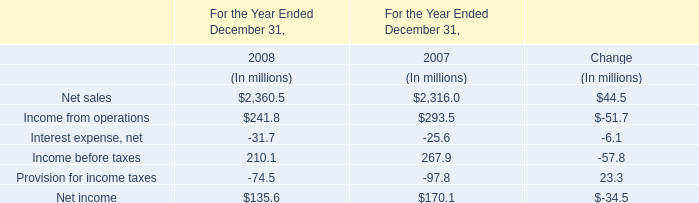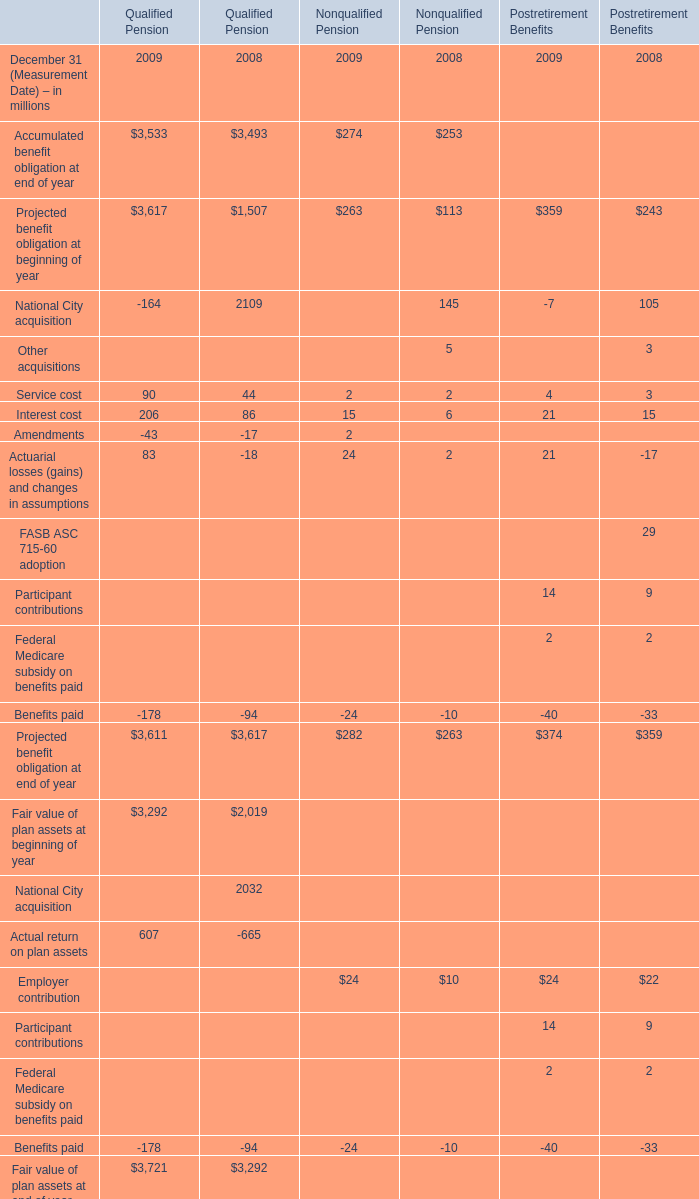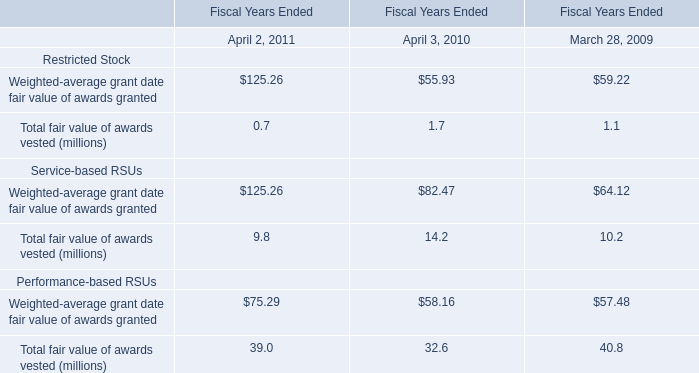In the year with the mostAccumulated benefit obligation at end of year forQualified Pension , what is the growth rate of Service cost? 
Computations: ((90 - 44) / 90)
Answer: 0.51111. 